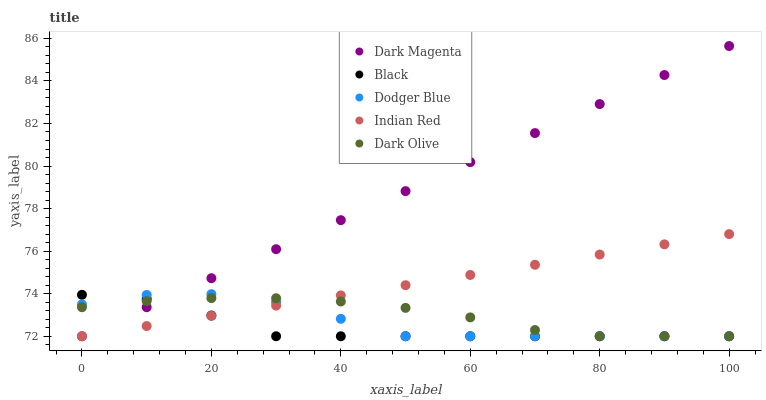Does Black have the minimum area under the curve?
Answer yes or no. Yes. Does Dark Magenta have the maximum area under the curve?
Answer yes or no. Yes. Does Dark Olive have the minimum area under the curve?
Answer yes or no. No. Does Dark Olive have the maximum area under the curve?
Answer yes or no. No. Is Indian Red the smoothest?
Answer yes or no. Yes. Is Dodger Blue the roughest?
Answer yes or no. Yes. Is Dark Olive the smoothest?
Answer yes or no. No. Is Dark Olive the roughest?
Answer yes or no. No. Does Dodger Blue have the lowest value?
Answer yes or no. Yes. Does Dark Magenta have the highest value?
Answer yes or no. Yes. Does Black have the highest value?
Answer yes or no. No. Does Indian Red intersect Dark Olive?
Answer yes or no. Yes. Is Indian Red less than Dark Olive?
Answer yes or no. No. Is Indian Red greater than Dark Olive?
Answer yes or no. No. 